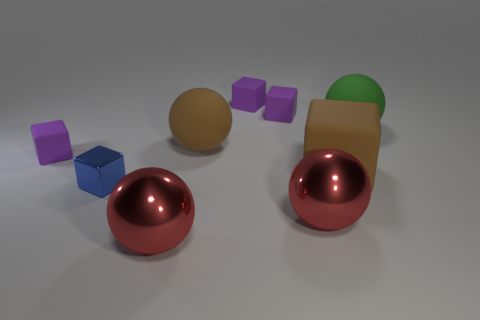The sphere that is the same color as the big block is what size?
Offer a very short reply. Large. There is a matte thing that is in front of the large brown sphere and to the right of the blue metal block; how big is it?
Your answer should be compact. Large. There is a large sphere that is the same color as the big rubber cube; what is its material?
Provide a succinct answer. Rubber. Are there an equal number of tiny purple rubber blocks right of the big brown ball and brown rubber things?
Ensure brevity in your answer.  Yes. Is the size of the green sphere the same as the blue metallic block?
Your response must be concise. No. What is the color of the small object that is both in front of the green ball and behind the blue metallic cube?
Keep it short and to the point. Purple. There is a purple cube that is in front of the large thing on the right side of the large matte cube; what is its material?
Your answer should be compact. Rubber. The other rubber thing that is the same shape as the big green rubber object is what size?
Give a very brief answer. Large. There is a large rubber ball to the left of the large cube; is it the same color as the large cube?
Provide a succinct answer. Yes. Are there fewer green cubes than red shiny things?
Your answer should be very brief. Yes. 